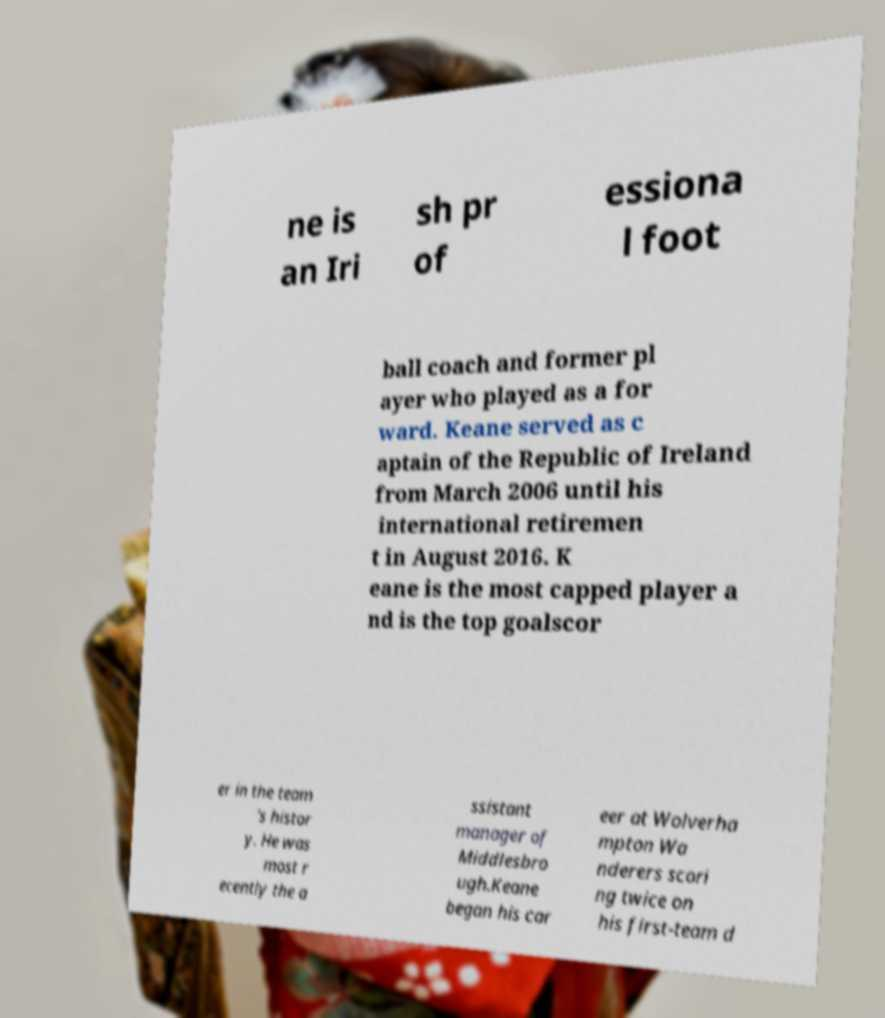There's text embedded in this image that I need extracted. Can you transcribe it verbatim? ne is an Iri sh pr of essiona l foot ball coach and former pl ayer who played as a for ward. Keane served as c aptain of the Republic of Ireland from March 2006 until his international retiremen t in August 2016. K eane is the most capped player a nd is the top goalscor er in the team 's histor y. He was most r ecently the a ssistant manager of Middlesbro ugh.Keane began his car eer at Wolverha mpton Wa nderers scori ng twice on his first-team d 